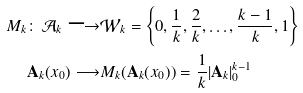Convert formula to latex. <formula><loc_0><loc_0><loc_500><loc_500>M _ { k } \colon \, \mathcal { A } _ { k } \longrightarrow & \mathcal { W } _ { k } = \left \{ 0 , \frac { 1 } { k } , \frac { 2 } { k } , \dots , \frac { k - 1 } { k } , 1 \right \} \\ \mathbf A _ { k } ( x _ { 0 } ) \longrightarrow & M _ { k } ( \mathbf A _ { k } ( x _ { 0 } ) ) = \frac { 1 } { k } | \mathbf A _ { k } | _ { 0 } ^ { k - 1 }</formula> 